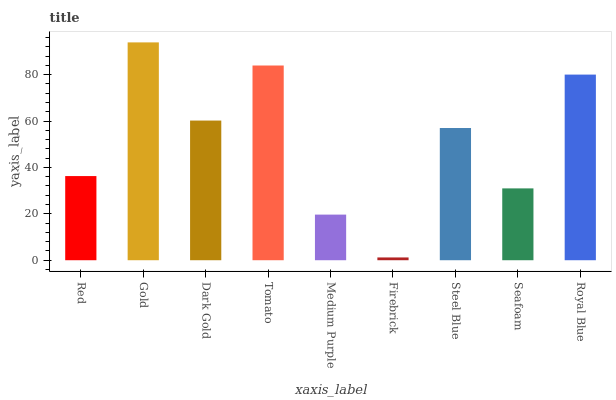Is Firebrick the minimum?
Answer yes or no. Yes. Is Gold the maximum?
Answer yes or no. Yes. Is Dark Gold the minimum?
Answer yes or no. No. Is Dark Gold the maximum?
Answer yes or no. No. Is Gold greater than Dark Gold?
Answer yes or no. Yes. Is Dark Gold less than Gold?
Answer yes or no. Yes. Is Dark Gold greater than Gold?
Answer yes or no. No. Is Gold less than Dark Gold?
Answer yes or no. No. Is Steel Blue the high median?
Answer yes or no. Yes. Is Steel Blue the low median?
Answer yes or no. Yes. Is Tomato the high median?
Answer yes or no. No. Is Gold the low median?
Answer yes or no. No. 